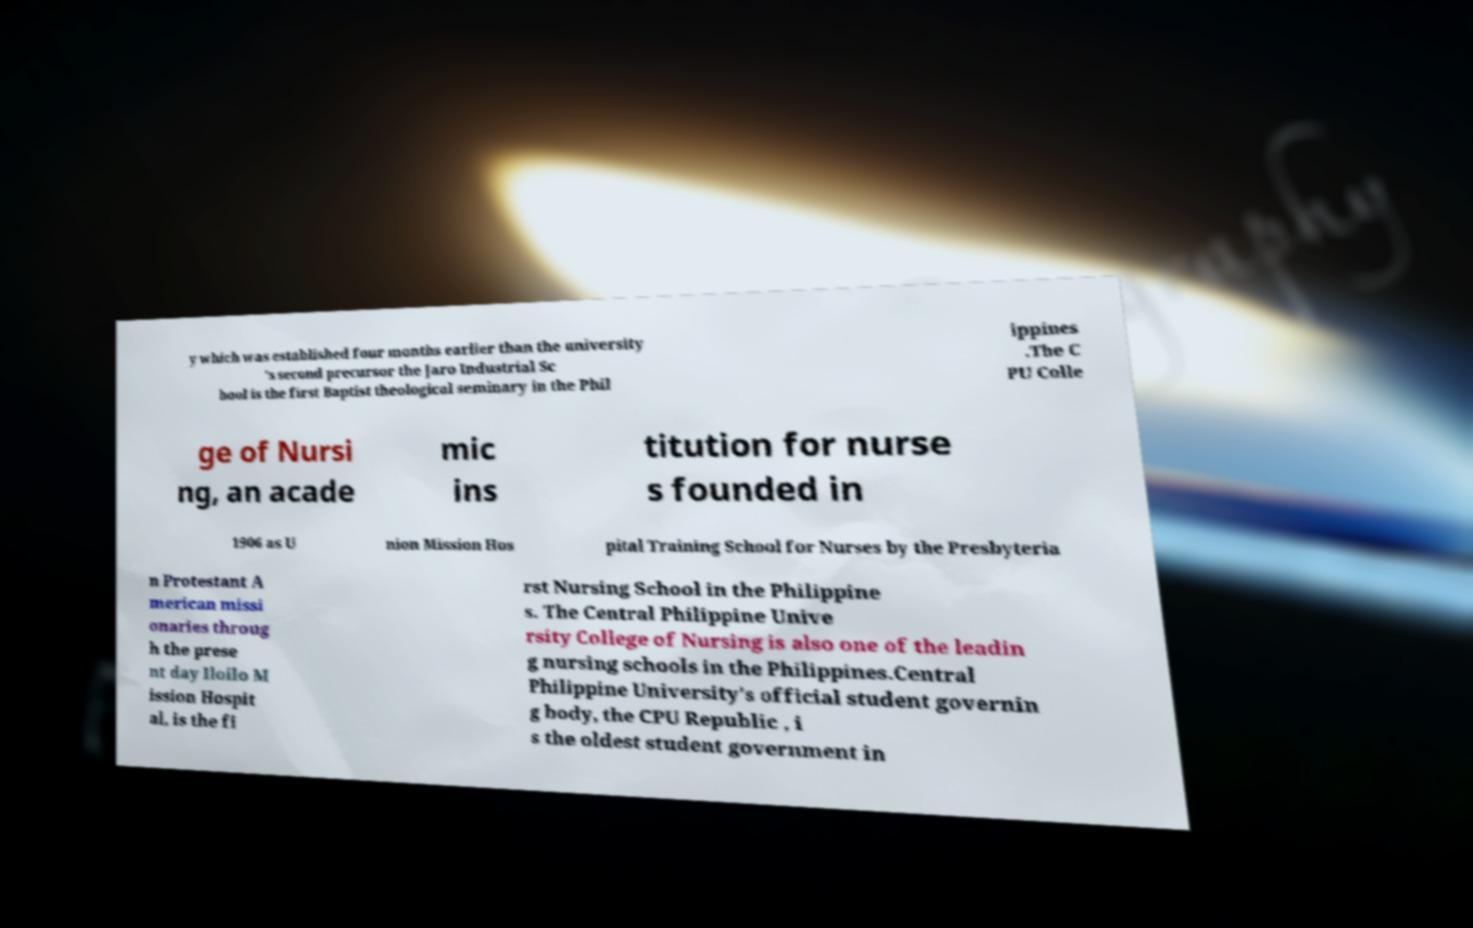Can you read and provide the text displayed in the image?This photo seems to have some interesting text. Can you extract and type it out for me? y which was established four months earlier than the university 's second precursor the Jaro Industrial Sc hool is the first Baptist theological seminary in the Phil ippines .The C PU Colle ge of Nursi ng, an acade mic ins titution for nurse s founded in 1906 as U nion Mission Hos pital Training School for Nurses by the Presbyteria n Protestant A merican missi onaries throug h the prese nt day Iloilo M ission Hospit al, is the fi rst Nursing School in the Philippine s. The Central Philippine Unive rsity College of Nursing is also one of the leadin g nursing schools in the Philippines.Central Philippine University's official student governin g body, the CPU Republic , i s the oldest student government in 